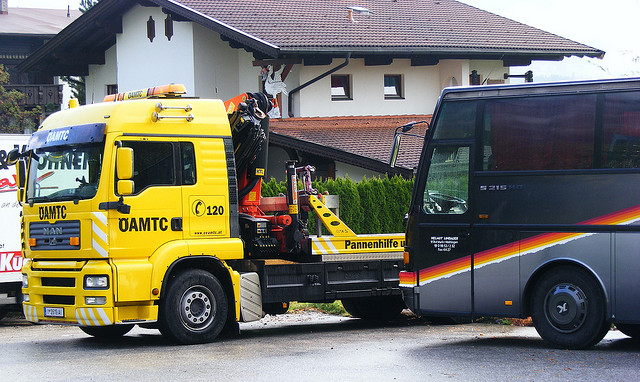<image>How many windows? I don't know the exact number of windows. There can be anywhere from 5 to 12. How many windows? I am not sure how many windows there are. It can be seen '12', '11', '5', '7', '6', 'truck two bus three house seven' or '8'. 